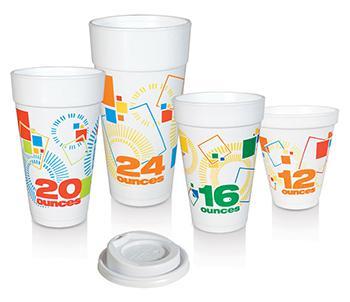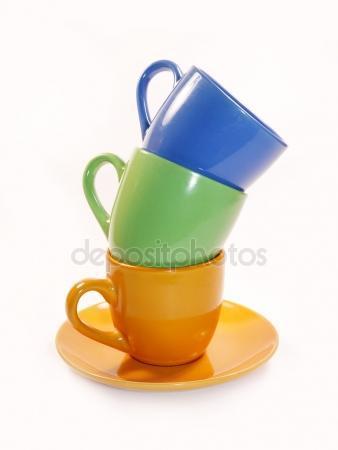The first image is the image on the left, the second image is the image on the right. Considering the images on both sides, is "There are more cups in the left image than in the right image." valid? Answer yes or no. Yes. The first image is the image on the left, the second image is the image on the right. For the images shown, is this caption "Some of the cups are stacked one on top of another" true? Answer yes or no. Yes. 